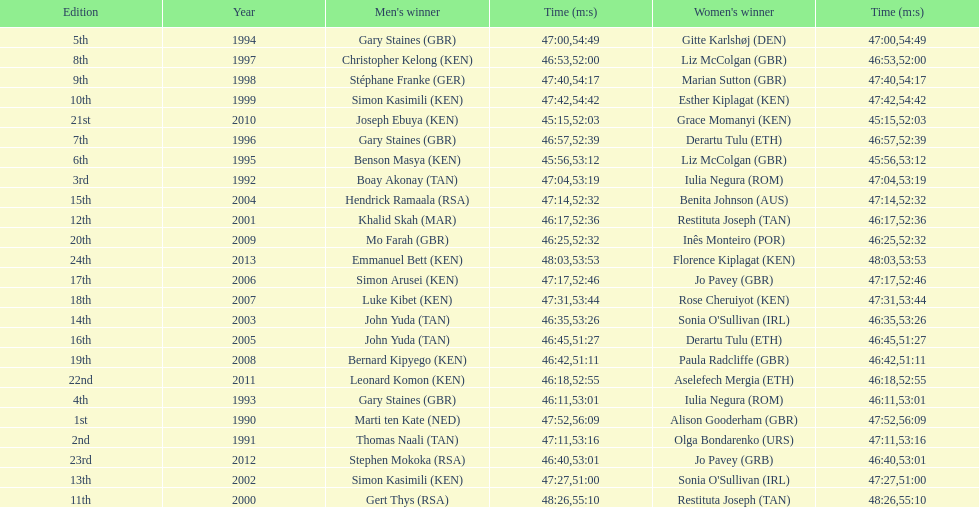What is the difference in finishing times for the men's and women's bupa great south run finish for 2013? 5:50. I'm looking to parse the entire table for insights. Could you assist me with that? {'header': ['Edition', 'Year', "Men's winner", 'Time (m:s)', "Women's winner", 'Time (m:s)'], 'rows': [['5th', '1994', 'Gary Staines\xa0(GBR)', '47:00', 'Gitte Karlshøj\xa0(DEN)', '54:49'], ['8th', '1997', 'Christopher Kelong\xa0(KEN)', '46:53', 'Liz McColgan\xa0(GBR)', '52:00'], ['9th', '1998', 'Stéphane Franke\xa0(GER)', '47:40', 'Marian Sutton\xa0(GBR)', '54:17'], ['10th', '1999', 'Simon Kasimili\xa0(KEN)', '47:42', 'Esther Kiplagat\xa0(KEN)', '54:42'], ['21st', '2010', 'Joseph Ebuya\xa0(KEN)', '45:15', 'Grace Momanyi\xa0(KEN)', '52:03'], ['7th', '1996', 'Gary Staines\xa0(GBR)', '46:57', 'Derartu Tulu\xa0(ETH)', '52:39'], ['6th', '1995', 'Benson Masya\xa0(KEN)', '45:56', 'Liz McColgan\xa0(GBR)', '53:12'], ['3rd', '1992', 'Boay Akonay\xa0(TAN)', '47:04', 'Iulia Negura\xa0(ROM)', '53:19'], ['15th', '2004', 'Hendrick Ramaala\xa0(RSA)', '47:14', 'Benita Johnson\xa0(AUS)', '52:32'], ['12th', '2001', 'Khalid Skah\xa0(MAR)', '46:17', 'Restituta Joseph\xa0(TAN)', '52:36'], ['20th', '2009', 'Mo Farah\xa0(GBR)', '46:25', 'Inês Monteiro\xa0(POR)', '52:32'], ['24th', '2013', 'Emmanuel Bett\xa0(KEN)', '48:03', 'Florence Kiplagat\xa0(KEN)', '53:53'], ['17th', '2006', 'Simon Arusei\xa0(KEN)', '47:17', 'Jo Pavey\xa0(GBR)', '52:46'], ['18th', '2007', 'Luke Kibet\xa0(KEN)', '47:31', 'Rose Cheruiyot\xa0(KEN)', '53:44'], ['14th', '2003', 'John Yuda\xa0(TAN)', '46:35', "Sonia O'Sullivan\xa0(IRL)", '53:26'], ['16th', '2005', 'John Yuda\xa0(TAN)', '46:45', 'Derartu Tulu\xa0(ETH)', '51:27'], ['19th', '2008', 'Bernard Kipyego\xa0(KEN)', '46:42', 'Paula Radcliffe\xa0(GBR)', '51:11'], ['22nd', '2011', 'Leonard Komon\xa0(KEN)', '46:18', 'Aselefech Mergia\xa0(ETH)', '52:55'], ['4th', '1993', 'Gary Staines\xa0(GBR)', '46:11', 'Iulia Negura\xa0(ROM)', '53:01'], ['1st', '1990', 'Marti ten Kate\xa0(NED)', '47:52', 'Alison Gooderham\xa0(GBR)', '56:09'], ['2nd', '1991', 'Thomas Naali\xa0(TAN)', '47:11', 'Olga Bondarenko\xa0(URS)', '53:16'], ['23rd', '2012', 'Stephen Mokoka\xa0(RSA)', '46:40', 'Jo Pavey\xa0(GRB)', '53:01'], ['13th', '2002', 'Simon Kasimili\xa0(KEN)', '47:27', "Sonia O'Sullivan\xa0(IRL)", '51:00'], ['11th', '2000', 'Gert Thys\xa0(RSA)', '48:26', 'Restituta Joseph\xa0(TAN)', '55:10']]} 